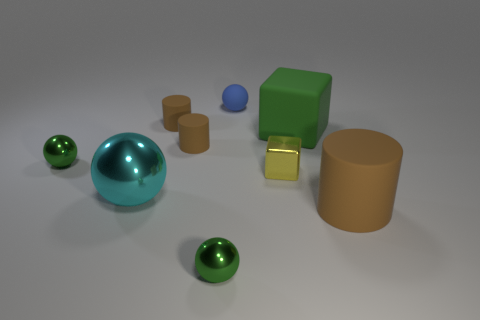Subtract all tiny blue rubber spheres. How many spheres are left? 3 Add 1 cyan things. How many objects exist? 10 Subtract all cyan spheres. How many spheres are left? 3 Subtract all blue cylinders. How many green balls are left? 2 Subtract all cubes. How many objects are left? 7 Subtract all large cyan shiny things. Subtract all green cubes. How many objects are left? 7 Add 2 tiny rubber cylinders. How many tiny rubber cylinders are left? 4 Add 8 large brown cylinders. How many large brown cylinders exist? 9 Subtract 0 purple blocks. How many objects are left? 9 Subtract 2 cylinders. How many cylinders are left? 1 